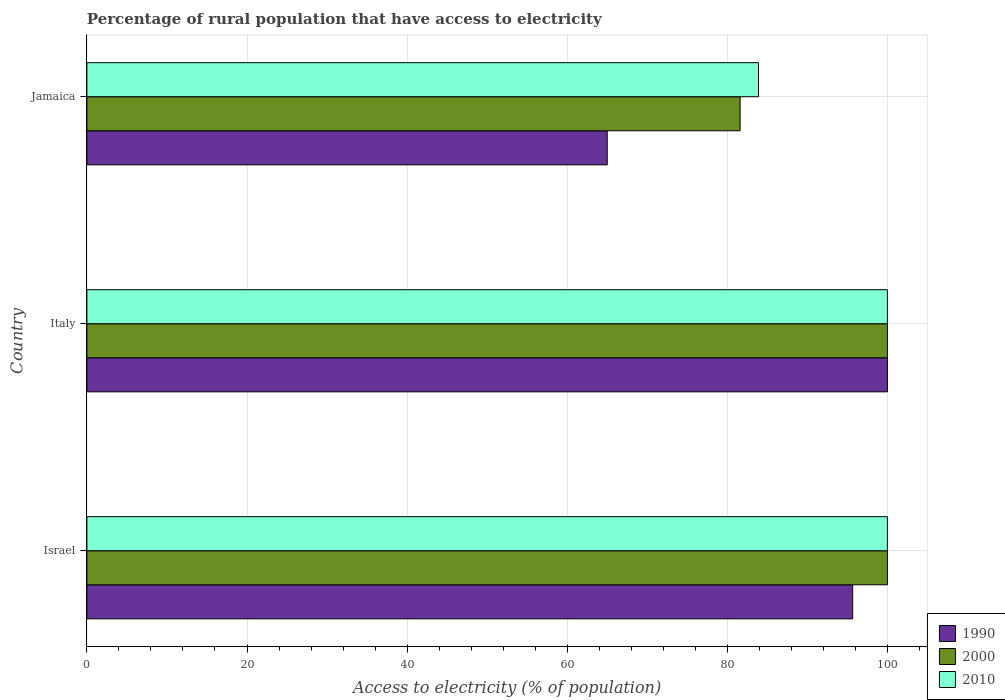How many different coloured bars are there?
Make the answer very short. 3. How many groups of bars are there?
Keep it short and to the point. 3. Are the number of bars on each tick of the Y-axis equal?
Your answer should be very brief. Yes. How many bars are there on the 2nd tick from the top?
Offer a terse response. 3. In how many cases, is the number of bars for a given country not equal to the number of legend labels?
Your answer should be compact. 0. What is the percentage of rural population that have access to electricity in 1990 in Israel?
Your answer should be very brief. 95.66. Across all countries, what is the minimum percentage of rural population that have access to electricity in 2000?
Make the answer very short. 81.6. In which country was the percentage of rural population that have access to electricity in 1990 minimum?
Your answer should be very brief. Jamaica. What is the total percentage of rural population that have access to electricity in 2010 in the graph?
Keep it short and to the point. 283.9. What is the difference between the percentage of rural population that have access to electricity in 1990 in Israel and that in Italy?
Offer a terse response. -4.34. What is the difference between the percentage of rural population that have access to electricity in 2000 in Israel and the percentage of rural population that have access to electricity in 2010 in Jamaica?
Give a very brief answer. 16.1. What is the average percentage of rural population that have access to electricity in 1990 per country?
Provide a short and direct response. 86.89. What is the difference between the percentage of rural population that have access to electricity in 2010 and percentage of rural population that have access to electricity in 2000 in Israel?
Offer a very short reply. 0. In how many countries, is the percentage of rural population that have access to electricity in 1990 greater than 8 %?
Your answer should be compact. 3. What is the ratio of the percentage of rural population that have access to electricity in 2010 in Israel to that in Jamaica?
Your response must be concise. 1.19. What is the difference between the highest and the lowest percentage of rural population that have access to electricity in 2010?
Your answer should be compact. 16.1. In how many countries, is the percentage of rural population that have access to electricity in 2010 greater than the average percentage of rural population that have access to electricity in 2010 taken over all countries?
Your answer should be very brief. 2. Is the sum of the percentage of rural population that have access to electricity in 2000 in Italy and Jamaica greater than the maximum percentage of rural population that have access to electricity in 2010 across all countries?
Your response must be concise. Yes. Are all the bars in the graph horizontal?
Your answer should be very brief. Yes. How many countries are there in the graph?
Your answer should be compact. 3. Does the graph contain any zero values?
Your answer should be compact. No. How many legend labels are there?
Your response must be concise. 3. How are the legend labels stacked?
Offer a very short reply. Vertical. What is the title of the graph?
Offer a very short reply. Percentage of rural population that have access to electricity. What is the label or title of the X-axis?
Your answer should be very brief. Access to electricity (% of population). What is the Access to electricity (% of population) of 1990 in Israel?
Your answer should be very brief. 95.66. What is the Access to electricity (% of population) of 2000 in Israel?
Your response must be concise. 100. What is the Access to electricity (% of population) in 2010 in Israel?
Keep it short and to the point. 100. What is the Access to electricity (% of population) in 2000 in Italy?
Provide a short and direct response. 100. What is the Access to electricity (% of population) in 2010 in Italy?
Your response must be concise. 100. What is the Access to electricity (% of population) of 2000 in Jamaica?
Make the answer very short. 81.6. What is the Access to electricity (% of population) of 2010 in Jamaica?
Offer a very short reply. 83.9. Across all countries, what is the maximum Access to electricity (% of population) in 2000?
Your answer should be very brief. 100. Across all countries, what is the maximum Access to electricity (% of population) in 2010?
Your answer should be very brief. 100. Across all countries, what is the minimum Access to electricity (% of population) in 1990?
Your answer should be very brief. 65. Across all countries, what is the minimum Access to electricity (% of population) in 2000?
Ensure brevity in your answer.  81.6. Across all countries, what is the minimum Access to electricity (% of population) in 2010?
Ensure brevity in your answer.  83.9. What is the total Access to electricity (% of population) of 1990 in the graph?
Offer a very short reply. 260.66. What is the total Access to electricity (% of population) of 2000 in the graph?
Your answer should be compact. 281.6. What is the total Access to electricity (% of population) of 2010 in the graph?
Your answer should be very brief. 283.9. What is the difference between the Access to electricity (% of population) of 1990 in Israel and that in Italy?
Provide a succinct answer. -4.34. What is the difference between the Access to electricity (% of population) in 2010 in Israel and that in Italy?
Your answer should be very brief. 0. What is the difference between the Access to electricity (% of population) of 1990 in Israel and that in Jamaica?
Keep it short and to the point. 30.66. What is the difference between the Access to electricity (% of population) of 2000 in Israel and that in Jamaica?
Ensure brevity in your answer.  18.4. What is the difference between the Access to electricity (% of population) in 2010 in Israel and that in Jamaica?
Keep it short and to the point. 16.1. What is the difference between the Access to electricity (% of population) in 1990 in Italy and that in Jamaica?
Your answer should be compact. 35. What is the difference between the Access to electricity (% of population) of 2000 in Italy and that in Jamaica?
Provide a succinct answer. 18.4. What is the difference between the Access to electricity (% of population) of 1990 in Israel and the Access to electricity (% of population) of 2000 in Italy?
Your response must be concise. -4.34. What is the difference between the Access to electricity (% of population) in 1990 in Israel and the Access to electricity (% of population) in 2010 in Italy?
Keep it short and to the point. -4.34. What is the difference between the Access to electricity (% of population) of 1990 in Israel and the Access to electricity (% of population) of 2000 in Jamaica?
Your answer should be very brief. 14.06. What is the difference between the Access to electricity (% of population) of 1990 in Israel and the Access to electricity (% of population) of 2010 in Jamaica?
Make the answer very short. 11.76. What is the difference between the Access to electricity (% of population) in 1990 in Italy and the Access to electricity (% of population) in 2010 in Jamaica?
Your answer should be very brief. 16.1. What is the difference between the Access to electricity (% of population) in 2000 in Italy and the Access to electricity (% of population) in 2010 in Jamaica?
Your response must be concise. 16.1. What is the average Access to electricity (% of population) of 1990 per country?
Your response must be concise. 86.89. What is the average Access to electricity (% of population) in 2000 per country?
Provide a succinct answer. 93.87. What is the average Access to electricity (% of population) of 2010 per country?
Offer a terse response. 94.63. What is the difference between the Access to electricity (% of population) in 1990 and Access to electricity (% of population) in 2000 in Israel?
Give a very brief answer. -4.34. What is the difference between the Access to electricity (% of population) of 1990 and Access to electricity (% of population) of 2010 in Israel?
Offer a very short reply. -4.34. What is the difference between the Access to electricity (% of population) in 2000 and Access to electricity (% of population) in 2010 in Israel?
Provide a short and direct response. 0. What is the difference between the Access to electricity (% of population) in 1990 and Access to electricity (% of population) in 2010 in Italy?
Ensure brevity in your answer.  0. What is the difference between the Access to electricity (% of population) in 1990 and Access to electricity (% of population) in 2000 in Jamaica?
Provide a succinct answer. -16.6. What is the difference between the Access to electricity (% of population) of 1990 and Access to electricity (% of population) of 2010 in Jamaica?
Your answer should be compact. -18.9. What is the ratio of the Access to electricity (% of population) in 1990 in Israel to that in Italy?
Make the answer very short. 0.96. What is the ratio of the Access to electricity (% of population) of 2000 in Israel to that in Italy?
Ensure brevity in your answer.  1. What is the ratio of the Access to electricity (% of population) of 2010 in Israel to that in Italy?
Offer a very short reply. 1. What is the ratio of the Access to electricity (% of population) of 1990 in Israel to that in Jamaica?
Provide a succinct answer. 1.47. What is the ratio of the Access to electricity (% of population) in 2000 in Israel to that in Jamaica?
Offer a terse response. 1.23. What is the ratio of the Access to electricity (% of population) of 2010 in Israel to that in Jamaica?
Make the answer very short. 1.19. What is the ratio of the Access to electricity (% of population) of 1990 in Italy to that in Jamaica?
Your answer should be compact. 1.54. What is the ratio of the Access to electricity (% of population) in 2000 in Italy to that in Jamaica?
Your answer should be compact. 1.23. What is the ratio of the Access to electricity (% of population) in 2010 in Italy to that in Jamaica?
Your answer should be compact. 1.19. What is the difference between the highest and the second highest Access to electricity (% of population) of 1990?
Give a very brief answer. 4.34. What is the difference between the highest and the second highest Access to electricity (% of population) in 2000?
Offer a terse response. 0. What is the difference between the highest and the second highest Access to electricity (% of population) in 2010?
Your answer should be compact. 0. What is the difference between the highest and the lowest Access to electricity (% of population) in 2000?
Your answer should be compact. 18.4. What is the difference between the highest and the lowest Access to electricity (% of population) of 2010?
Your response must be concise. 16.1. 